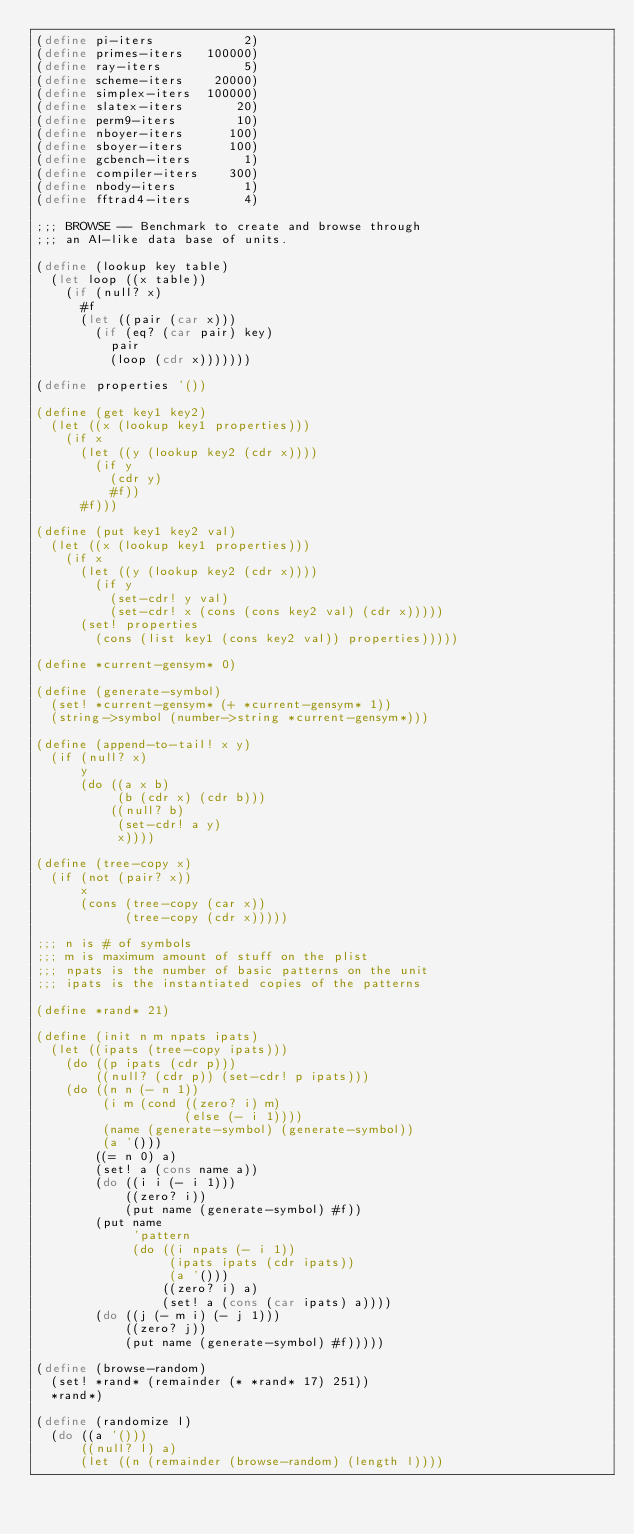Convert code to text. <code><loc_0><loc_0><loc_500><loc_500><_Scheme_>(define pi-iters            2)
(define primes-iters   100000)
(define ray-iters           5)
(define scheme-iters    20000)
(define simplex-iters  100000)
(define slatex-iters       20)
(define perm9-iters        10)
(define nboyer-iters      100)
(define sboyer-iters      100)
(define gcbench-iters       1)
(define compiler-iters    300)
(define nbody-iters         1)
(define fftrad4-iters       4)

;;; BROWSE -- Benchmark to create and browse through
;;; an AI-like data base of units.

(define (lookup key table)
  (let loop ((x table))
    (if (null? x)
      #f
      (let ((pair (car x)))
        (if (eq? (car pair) key)
          pair
          (loop (cdr x)))))))

(define properties '())

(define (get key1 key2)
  (let ((x (lookup key1 properties)))
    (if x
      (let ((y (lookup key2 (cdr x))))
        (if y
          (cdr y)
          #f))
      #f)))

(define (put key1 key2 val)
  (let ((x (lookup key1 properties)))
    (if x
      (let ((y (lookup key2 (cdr x))))
        (if y
          (set-cdr! y val)
          (set-cdr! x (cons (cons key2 val) (cdr x)))))
      (set! properties
        (cons (list key1 (cons key2 val)) properties)))))

(define *current-gensym* 0)

(define (generate-symbol)
  (set! *current-gensym* (+ *current-gensym* 1))
  (string->symbol (number->string *current-gensym*)))

(define (append-to-tail! x y)
  (if (null? x)
      y
      (do ((a x b)
           (b (cdr x) (cdr b)))
          ((null? b)
           (set-cdr! a y)
           x))))

(define (tree-copy x)
  (if (not (pair? x))
      x
      (cons (tree-copy (car x))
            (tree-copy (cdr x)))))

;;; n is # of symbols
;;; m is maximum amount of stuff on the plist
;;; npats is the number of basic patterns on the unit
;;; ipats is the instantiated copies of the patterns

(define *rand* 21)

(define (init n m npats ipats)
  (let ((ipats (tree-copy ipats)))
    (do ((p ipats (cdr p)))
        ((null? (cdr p)) (set-cdr! p ipats)))
    (do ((n n (- n 1))
         (i m (cond ((zero? i) m)
                    (else (- i 1))))
         (name (generate-symbol) (generate-symbol))
         (a '()))
        ((= n 0) a)
        (set! a (cons name a))
        (do ((i i (- i 1)))
            ((zero? i))
            (put name (generate-symbol) #f))
        (put name
             'pattern
             (do ((i npats (- i 1))
                  (ipats ipats (cdr ipats))
                  (a '()))
                 ((zero? i) a)
                 (set! a (cons (car ipats) a))))
        (do ((j (- m i) (- j 1)))
            ((zero? j))
            (put name (generate-symbol) #f)))))

(define (browse-random)
  (set! *rand* (remainder (* *rand* 17) 251))
  *rand*)

(define (randomize l)
  (do ((a '()))
      ((null? l) a)
      (let ((n (remainder (browse-random) (length l))))</code> 